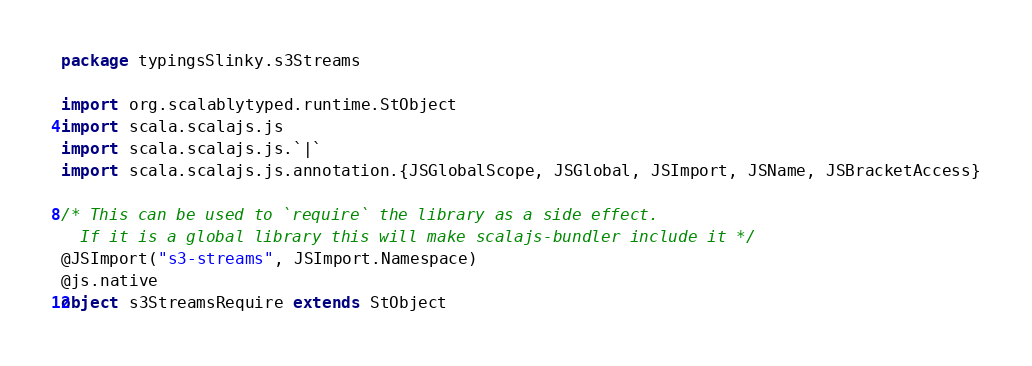Convert code to text. <code><loc_0><loc_0><loc_500><loc_500><_Scala_>package typingsSlinky.s3Streams

import org.scalablytyped.runtime.StObject
import scala.scalajs.js
import scala.scalajs.js.`|`
import scala.scalajs.js.annotation.{JSGlobalScope, JSGlobal, JSImport, JSName, JSBracketAccess}

/* This can be used to `require` the library as a side effect.
  If it is a global library this will make scalajs-bundler include it */
@JSImport("s3-streams", JSImport.Namespace)
@js.native
object s3StreamsRequire extends StObject
</code> 